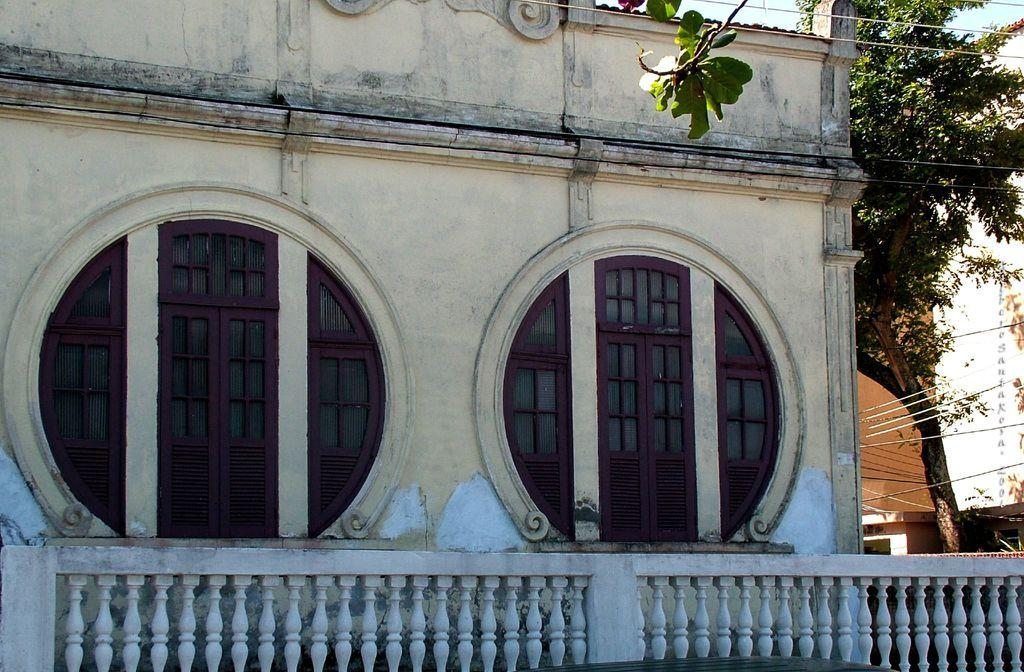What type of structure is present in the image? There is a building in the image. What can be seen near the building? There is a cement railing in the image. What type of vegetation is on the right side of the image? There is a tree on the right side of the image. What else is visible in the image? There are wires visible in the image. How many ducks are sitting on the cement railing in the image? There are no ducks present in the image; it only features a building, a cement railing, a tree, and wires. 